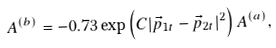<formula> <loc_0><loc_0><loc_500><loc_500>A ^ { ( b ) } = - 0 . 7 3 \exp \left ( C | { \vec { p } } _ { 1 t } - { \vec { p } } _ { 2 t } | ^ { 2 } \right ) A ^ { ( a ) } ,</formula> 